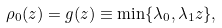<formula> <loc_0><loc_0><loc_500><loc_500>\rho _ { 0 } ( z ) = g ( z ) \equiv \min \{ \lambda _ { 0 } , \lambda _ { 1 } z \} ,</formula> 